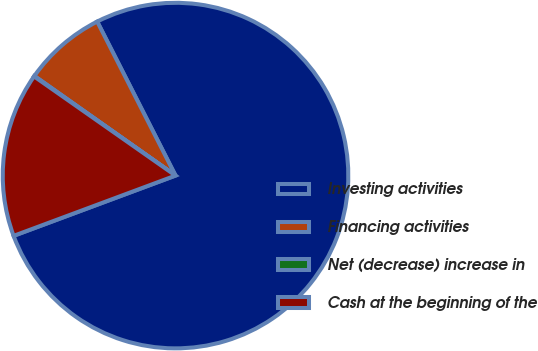Convert chart to OTSL. <chart><loc_0><loc_0><loc_500><loc_500><pie_chart><fcel>Investing activities<fcel>Financing activities<fcel>Net (decrease) increase in<fcel>Cash at the beginning of the<nl><fcel>76.81%<fcel>7.73%<fcel>0.05%<fcel>15.4%<nl></chart> 